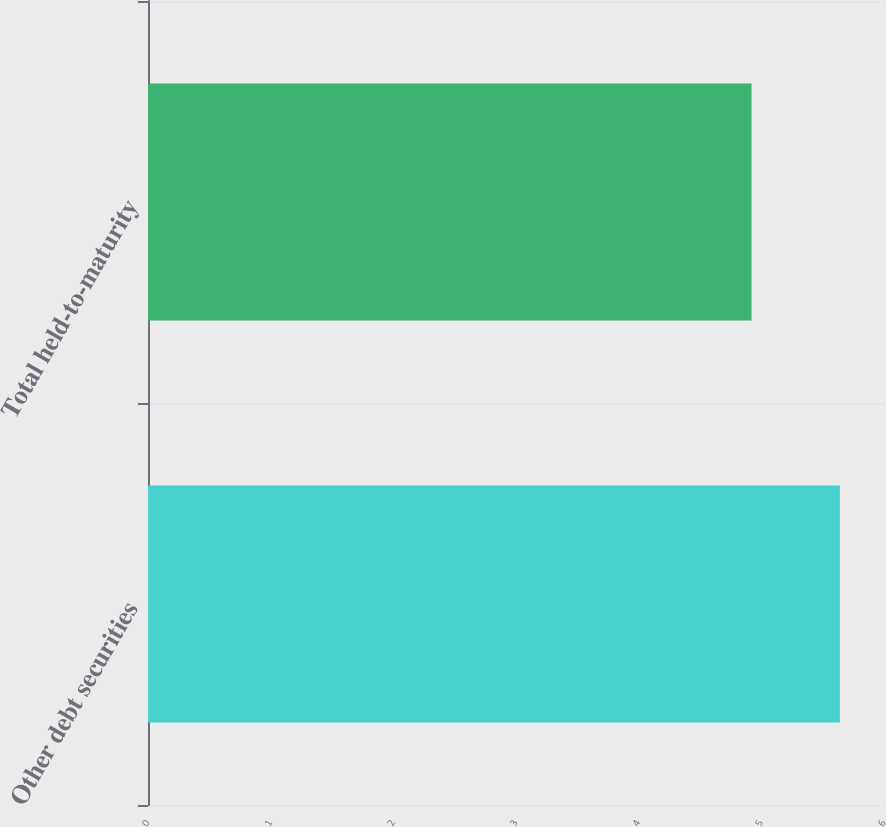<chart> <loc_0><loc_0><loc_500><loc_500><bar_chart><fcel>Other debt securities<fcel>Total held-to-maturity<nl><fcel>5.64<fcel>4.92<nl></chart> 